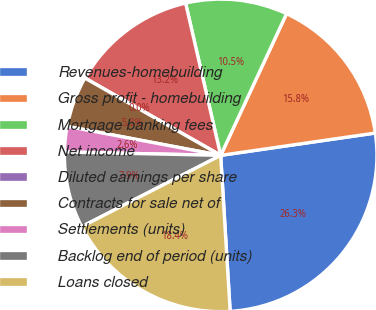<chart> <loc_0><loc_0><loc_500><loc_500><pie_chart><fcel>Revenues-homebuilding<fcel>Gross profit - homebuilding<fcel>Mortgage banking fees<fcel>Net income<fcel>Diluted earnings per share<fcel>Contracts for sale net of<fcel>Settlements (units)<fcel>Backlog end of period (units)<fcel>Loans closed<nl><fcel>26.32%<fcel>15.79%<fcel>10.53%<fcel>13.16%<fcel>0.0%<fcel>5.26%<fcel>2.63%<fcel>7.89%<fcel>18.42%<nl></chart> 